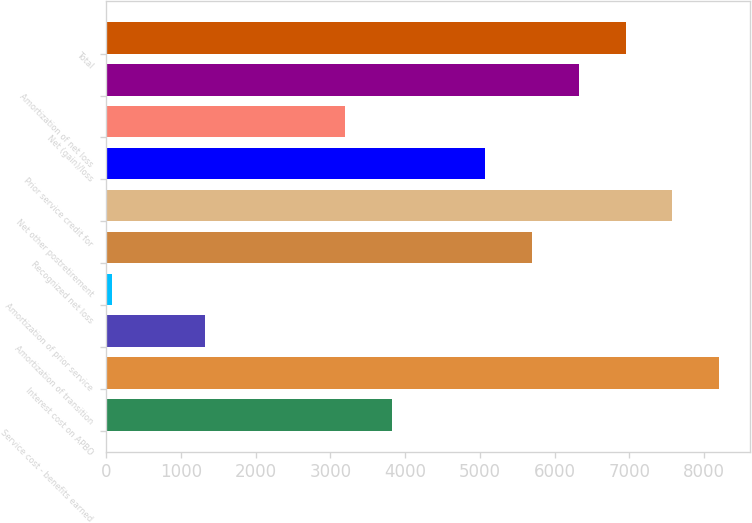Convert chart. <chart><loc_0><loc_0><loc_500><loc_500><bar_chart><fcel>Service cost - benefits earned<fcel>Interest cost on APBO<fcel>Amortization of transition<fcel>Amortization of prior service<fcel>Recognized net loss<fcel>Net other postretirement<fcel>Prior service credit for<fcel>Net (gain)/loss<fcel>Amortization of net loss<fcel>Total<nl><fcel>3826<fcel>8201<fcel>1326<fcel>76<fcel>5701<fcel>7576<fcel>5076<fcel>3201<fcel>6326<fcel>6951<nl></chart> 